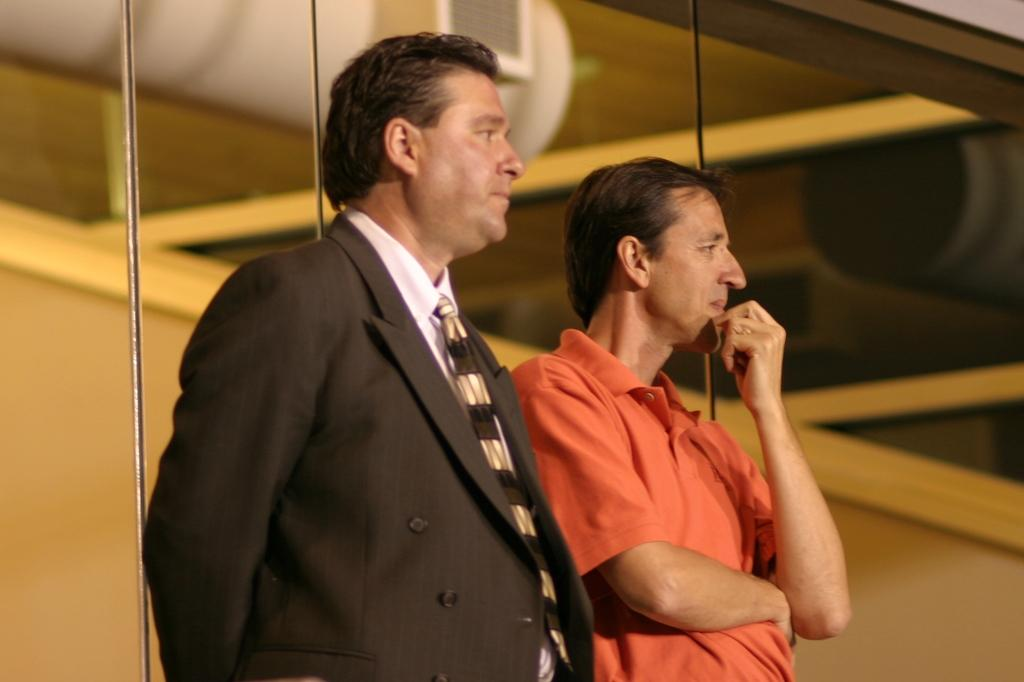How many people are in the image? There are two men standing in the image. What are the men wearing? The men are wearing clothes. What is the material of the wall in the image? There is a glass wall in the image. Can you describe the background of the image? The background of the image is blurred. What book is the mother reading to the children in the image? There is no mother or children present in the image, nor is there any book or reading activity depicted. 